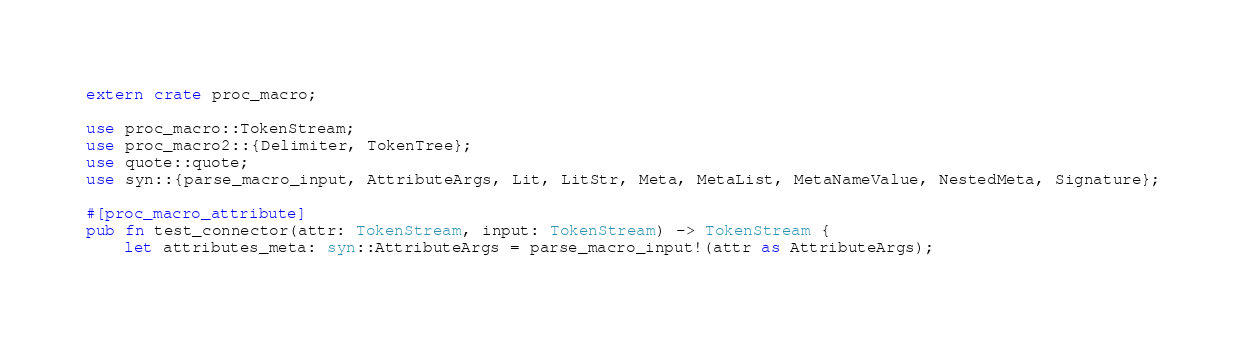Convert code to text. <code><loc_0><loc_0><loc_500><loc_500><_Rust_>extern crate proc_macro;

use proc_macro::TokenStream;
use proc_macro2::{Delimiter, TokenTree};
use quote::quote;
use syn::{parse_macro_input, AttributeArgs, Lit, LitStr, Meta, MetaList, MetaNameValue, NestedMeta, Signature};

#[proc_macro_attribute]
pub fn test_connector(attr: TokenStream, input: TokenStream) -> TokenStream {
    let attributes_meta: syn::AttributeArgs = parse_macro_input!(attr as AttributeArgs);</code> 